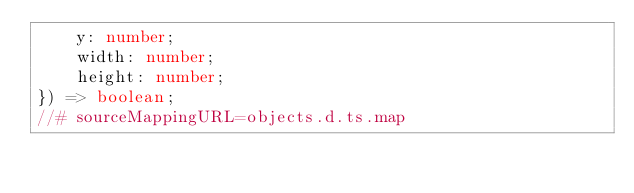Convert code to text. <code><loc_0><loc_0><loc_500><loc_500><_TypeScript_>    y: number;
    width: number;
    height: number;
}) => boolean;
//# sourceMappingURL=objects.d.ts.map
</code> 